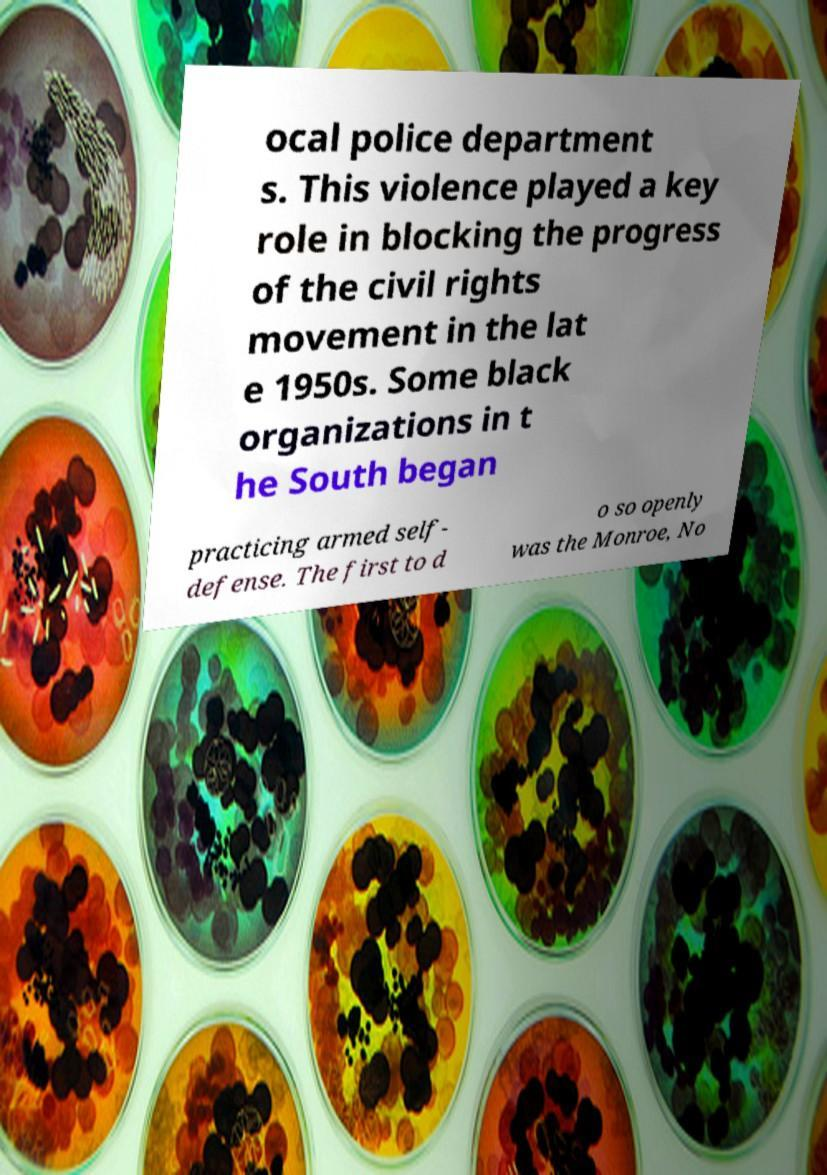Can you accurately transcribe the text from the provided image for me? ocal police department s. This violence played a key role in blocking the progress of the civil rights movement in the lat e 1950s. Some black organizations in t he South began practicing armed self- defense. The first to d o so openly was the Monroe, No 